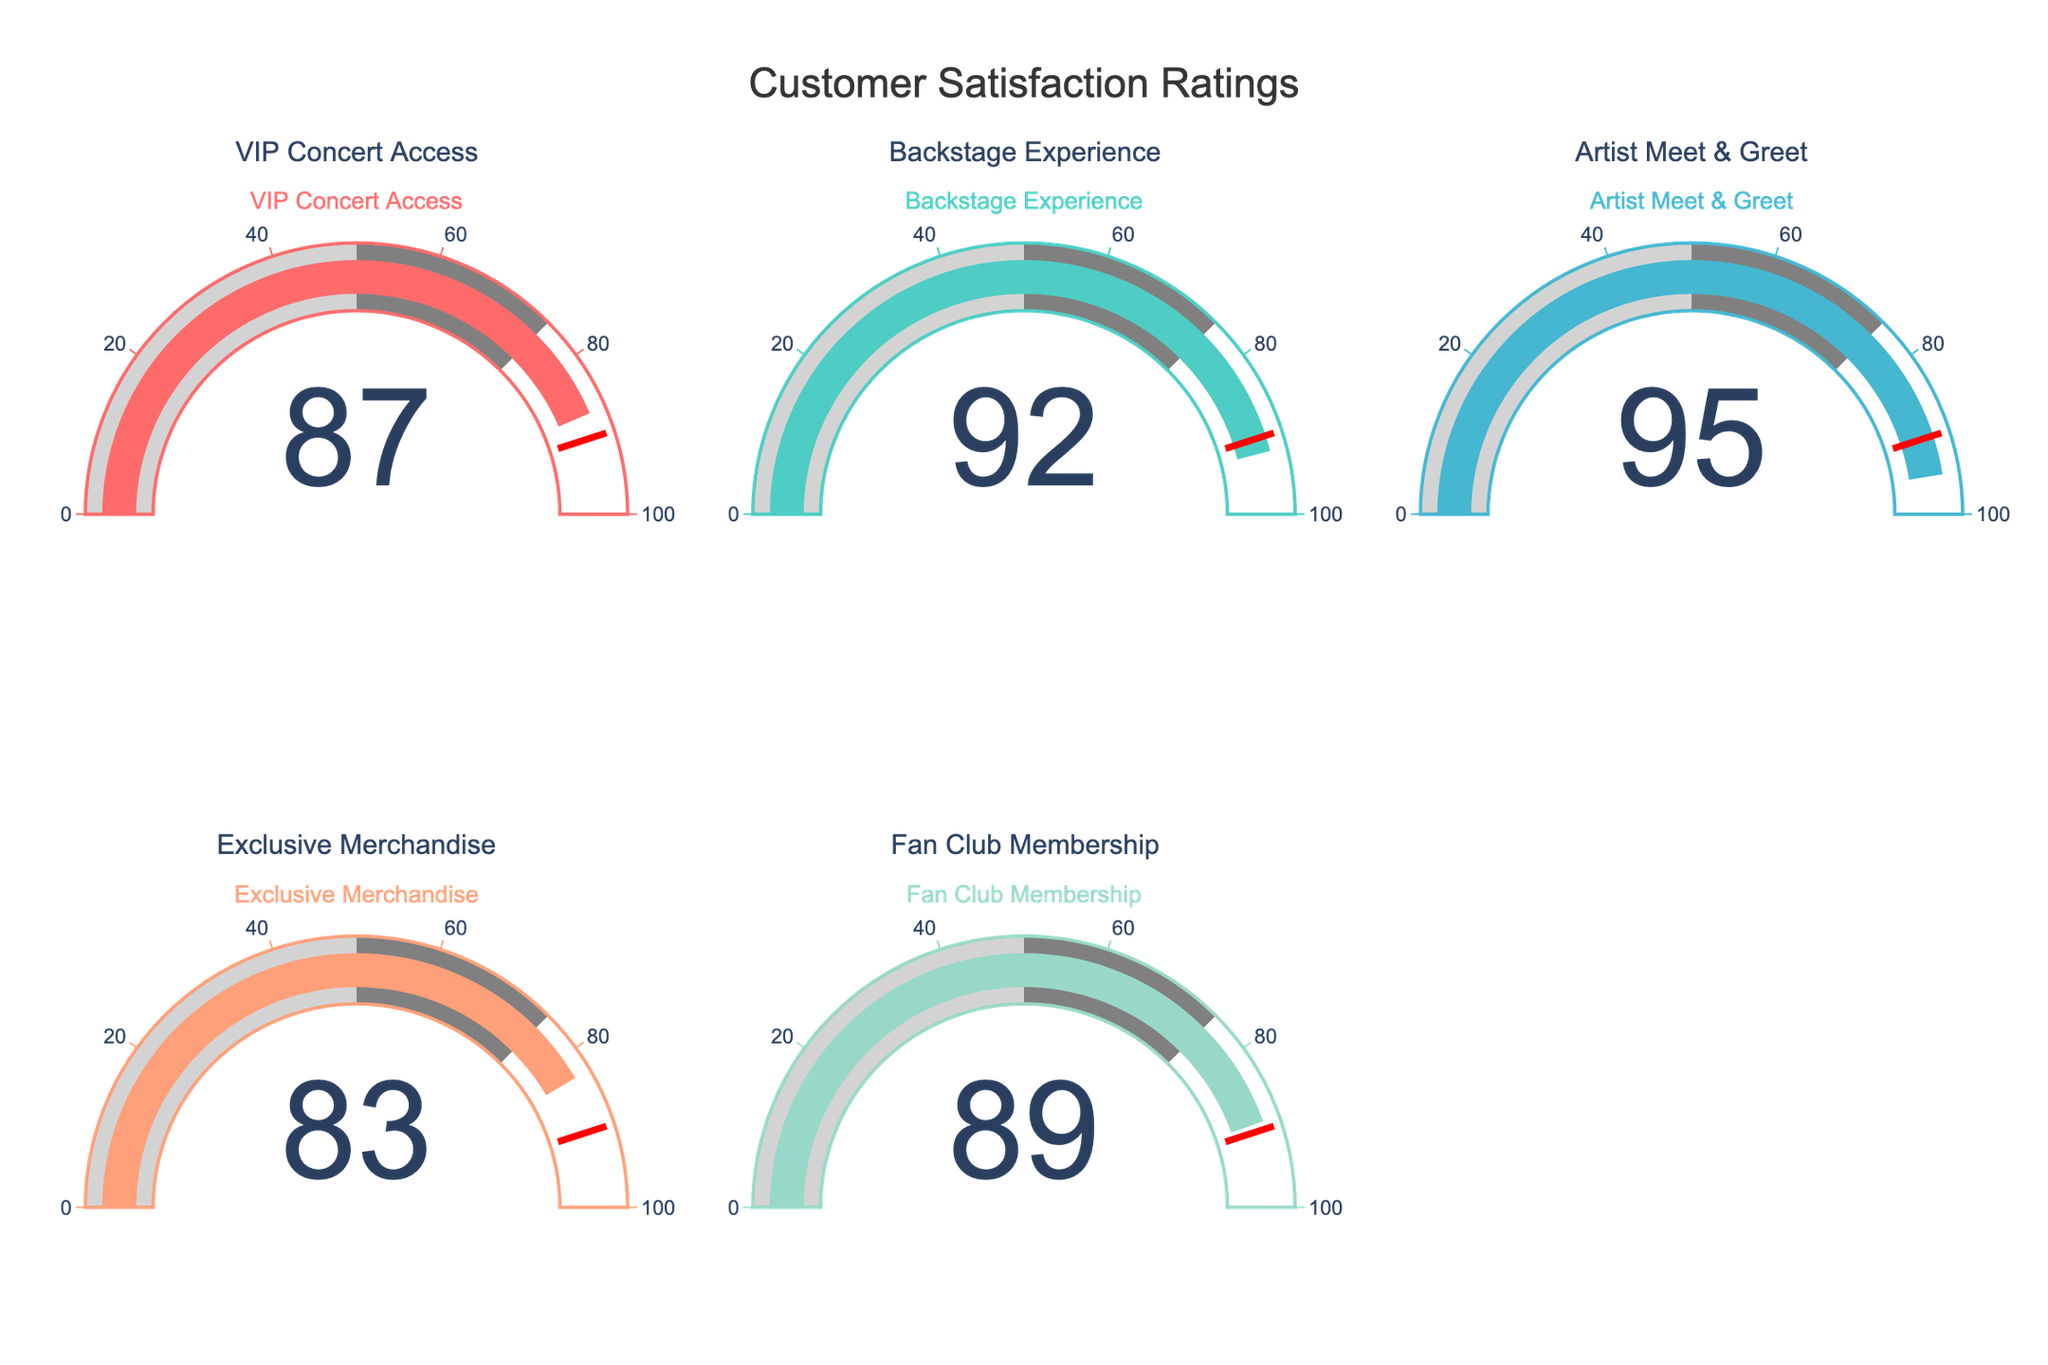What is the title of the figure? The title is displayed at the top of the figure in a large, bold font. It reads "Customer Satisfaction Ratings".
Answer: Customer Satisfaction Ratings How many services are evaluated in the figure? Each gauge chart corresponds to one service, and there are five gauge charts in total, making it five services.
Answer: Five Which service has the highest customer satisfaction rating? Examination of each gauge chart's displayed value shows the highest rating is 95, which corresponds to the "Artist Meet & Greet" service.
Answer: Artist Meet & Greet What is the average satisfaction rating across all services? Add the satisfaction ratings of all services: 87 (VIP Concert Access) + 92 (Backstage Experience) + 95 (Artist Meet & Greet) + 83 (Exclusive Merchandise) + 89 (Fan Club Membership) = 446. Then, divide by the number of services (5): 446/5 = 89.2
Answer: 89.2 What threshold value is used for the gauge charts? The threshold line, indicated in red on each gauge chart, is set at the value of 90.
Answer: 90 Which services fall below the satisfaction threshold? Comparing each service's rating to the threshold of 90, the services with ratings below 90 are: VIP Concert Access (87) and Exclusive Merchandise (83).
Answer: VIP Concert Access, Exclusive Merchandise Which gauge uses a light blue color for its satisfaction bar? By identifying the color palette used, the gauge chart for the "Backstage Experience" employs a light blue color in its bar.
Answer: Backstage Experience What is the total sum of all satisfaction ratings? Add up all the satisfaction ratings provided: 87 (VIP Concert Access) + 92 (Backstage Experience) + 95 (Artist Meet & Greet) + 83 (Exclusive Merchandise) + 89 (Fan Club Membership) = 446.
Answer: 446 What is the difference between the highest and lowest satisfaction ratings? Subtract the lowest rating (83, Exclusive Merchandise) from the highest rating (95, Artist Meet & Greet): 95 - 83 = 12.
Answer: 12 